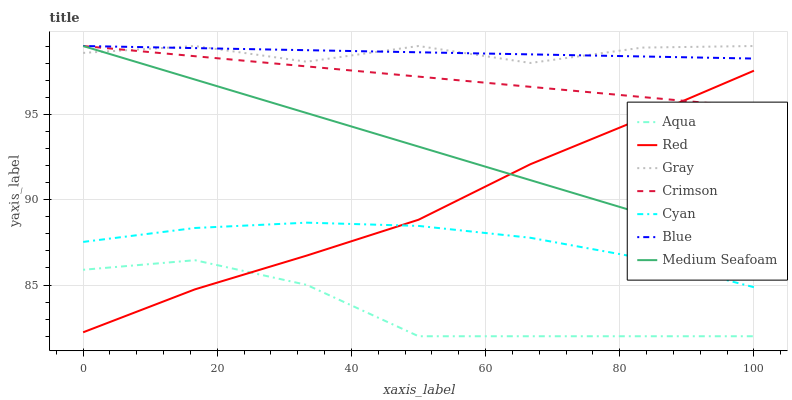Does Aqua have the minimum area under the curve?
Answer yes or no. Yes. Does Blue have the maximum area under the curve?
Answer yes or no. Yes. Does Gray have the minimum area under the curve?
Answer yes or no. No. Does Gray have the maximum area under the curve?
Answer yes or no. No. Is Medium Seafoam the smoothest?
Answer yes or no. Yes. Is Gray the roughest?
Answer yes or no. Yes. Is Aqua the smoothest?
Answer yes or no. No. Is Aqua the roughest?
Answer yes or no. No. Does Aqua have the lowest value?
Answer yes or no. Yes. Does Gray have the lowest value?
Answer yes or no. No. Does Medium Seafoam have the highest value?
Answer yes or no. Yes. Does Aqua have the highest value?
Answer yes or no. No. Is Red less than Blue?
Answer yes or no. Yes. Is Gray greater than Red?
Answer yes or no. Yes. Does Medium Seafoam intersect Gray?
Answer yes or no. Yes. Is Medium Seafoam less than Gray?
Answer yes or no. No. Is Medium Seafoam greater than Gray?
Answer yes or no. No. Does Red intersect Blue?
Answer yes or no. No. 